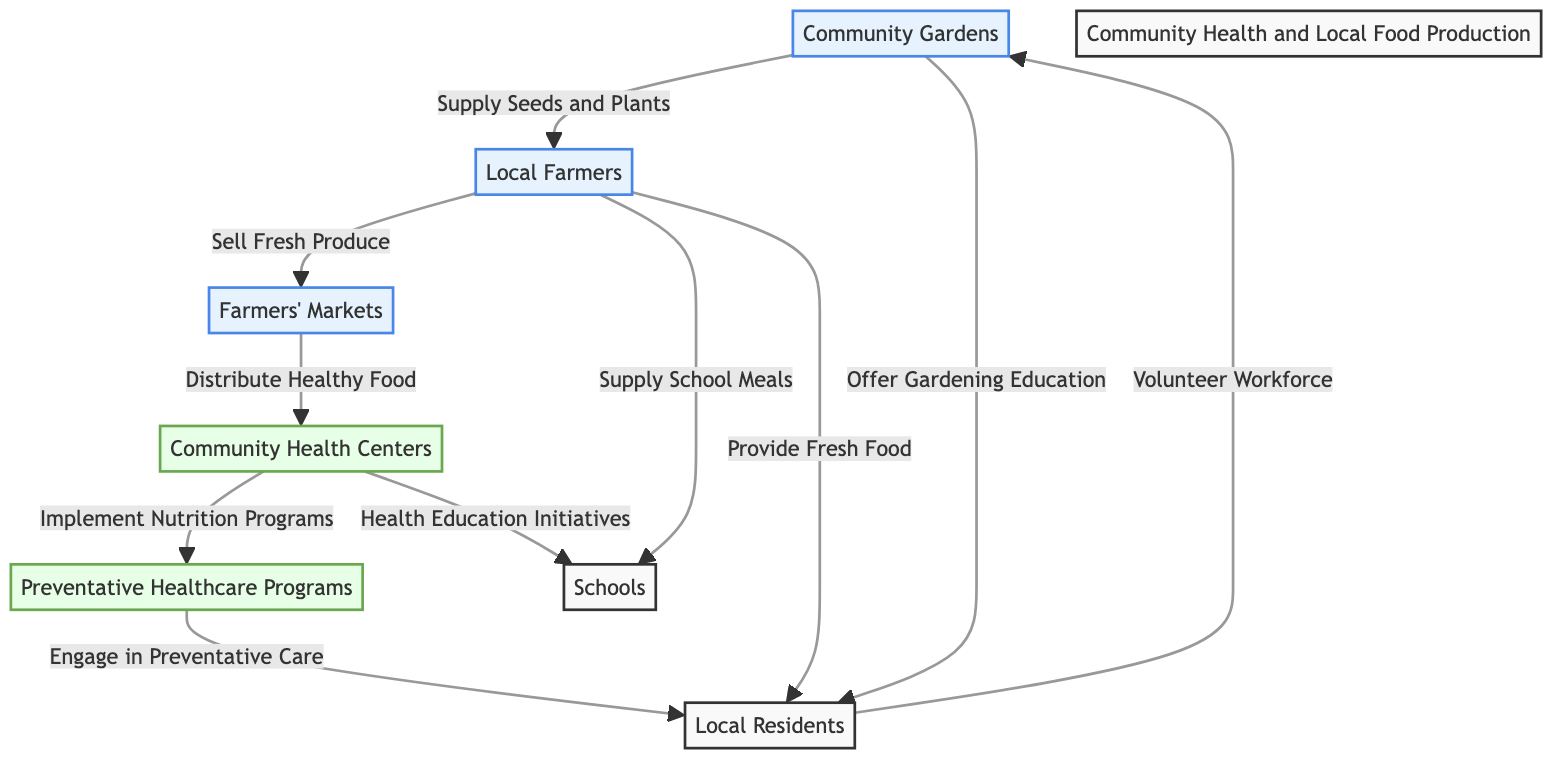What is the first node in the diagram? The first node is "Community Gardens," which is labeled at the top of the diagram and indicates the starting point of the food chain.
Answer: Community Gardens How many nodes are represented in the diagram? There are 6 unique nodes visually present in the diagram, including community nodes, healthcare nodes, and the local residents and schools.
Answer: 6 Which node connects "Local Farmers" to "Farmers' Markets"? The arrow signifies that "Local Farmers" connects to "Farmers' Markets" by the relationship described as "Sell Fresh Produce," indicating the direct interaction between these two nodes in the food chain.
Answer: Sell Fresh Produce What is the role of the "Community Health Centers"? The "Community Health Centers" node indicates its role in the flow by receiving healthy food distributed from the "Farmers' Markets" and subsequently implementing nutrition programs to promote health.
Answer: Implement Nutrition Programs How do "Schools" engage with the local food system? "Schools" engage in the local food system by receiving supply from "Local Farmers" for school meals and participating in health education initiatives from "Community Health Centers."
Answer: Supply School Meals and Health Education Initiatives What is the connection between "Farmers' Markets" and "Preventative Healthcare Programs"? The arrow shows that "Farmers' Markets" distribute healthy food to "Community Health Centers," which then implement nutrition programs leading directly to "Preventative Healthcare Programs." This indicates a progression towards health initiatives based on food access.
Answer: Distribute Healthy Food How do local residents support community gardens? Local residents contribute to community gardens by providing a volunteer workforce, which helps in the maintenance and growth of such gardens, reinforcing the community's role in food production.
Answer: Volunteer Workforce What type of educational initiatives do "Community Health Centers" provide? "Community Health Centers" provide health education initiatives aimed at schools, thus focusing on educating students about nutrition and healthy lifestyles as part of their preventive care approach.
Answer: Health Education Initiatives 